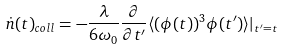<formula> <loc_0><loc_0><loc_500><loc_500>\dot { n } ( t ) _ { c o l l } = - \frac { \lambda } { 6 \omega _ { 0 } } \frac { \partial } { \partial t ^ { \prime } } \langle ( \phi ( t ) ) ^ { 3 } \phi ( t ^ { \prime } ) \rangle | _ { t ^ { \prime } = t }</formula> 